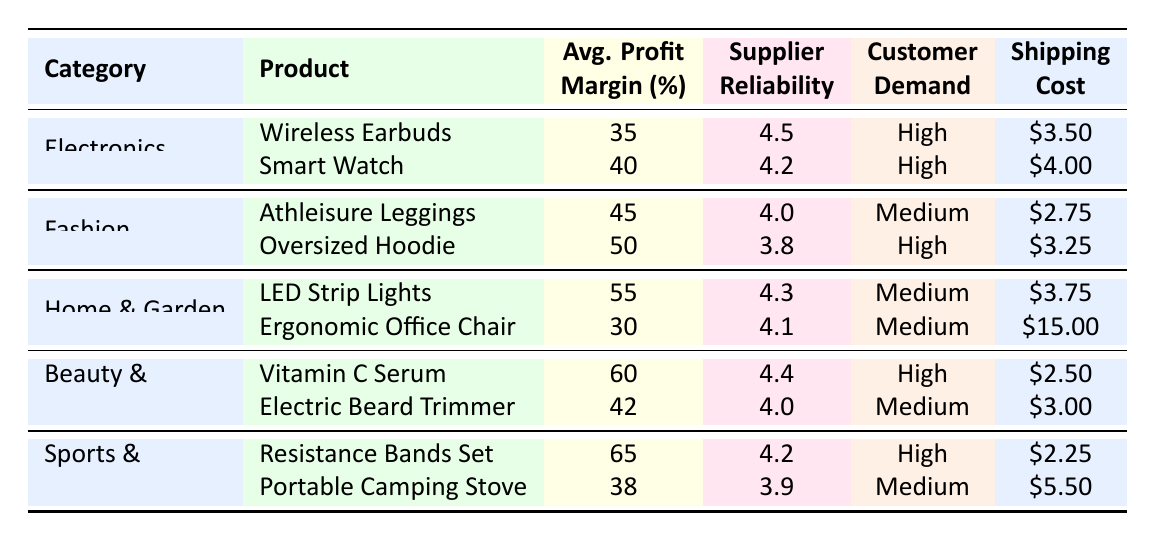What is the average profit margin for products in the Fashion category? The profit margins for the Fashion category are 45% for Athleisure Leggings and 50% for Oversized Hoodie. To find the average, we sum these margins (45 + 50) = 95 and then divide by the number of products (2), resulting in an average of 95/2 = 47.5.
Answer: 47.5 Which product has the highest profit margin in the table? Looking through the profit margins listed, the Resistance Bands Set in the Sports & Outdoors category has the highest profit margin at 65%.
Answer: 65% Is the customer demand for the Smart Watch high? According to the table, the customer demand for the Smart Watch is listed as "High." Thus, the answer is yes.
Answer: Yes Which category has a product that offers a shipping cost of $2.25? The shipping cost of $2.25 corresponds to the Resistance Bands Set in the Sports & Outdoors category. Therefore, the answer is that the Sports & Outdoors category includes this product.
Answer: Sports & Outdoors How many products have an average profit margin above 50%? The products with profit margins above 50% are: LED Strip Lights (55%), Vitamin C Serum (60%), and Resistance Bands Set (65%). This gives us a total of 3 products that meet the criteria.
Answer: 3 Are there any products in the Beauty & Personal Care category with a supplier reliability score below 4? From the table, we see that the Electric Beard Trimmer has a supplier reliability score of 4.0, which is not below 4. Therefore, there are no products in the Beauty & Personal Care category with a score below 4.
Answer: No What is the difference in average profit margin between the Electronics and Sports & Outdoors categories? The average profit margins for Electronics are 37.5% ((35 + 40) / 2) and for Sports & Outdoors it's 51.5% ((65 + 38) / 2). The difference is 51.5 - 37.5 = 14%.
Answer: 14% Which product has both high customer demand and the lowest shipping cost? The product that satisfies high customer demand and has the lowest shipping cost is the Resistance Bands Set, with a shipping cost of $2.25.
Answer: Resistance Bands Set What is the average supplier reliability score for the Home & Garden products? The supplier reliability scores for Home & Garden products are 4.3 for LED Strip Lights and 4.1 for Ergonomic Office Chair. Calculating the average: (4.3 + 4.1) / 2 = 4.2.
Answer: 4.2 